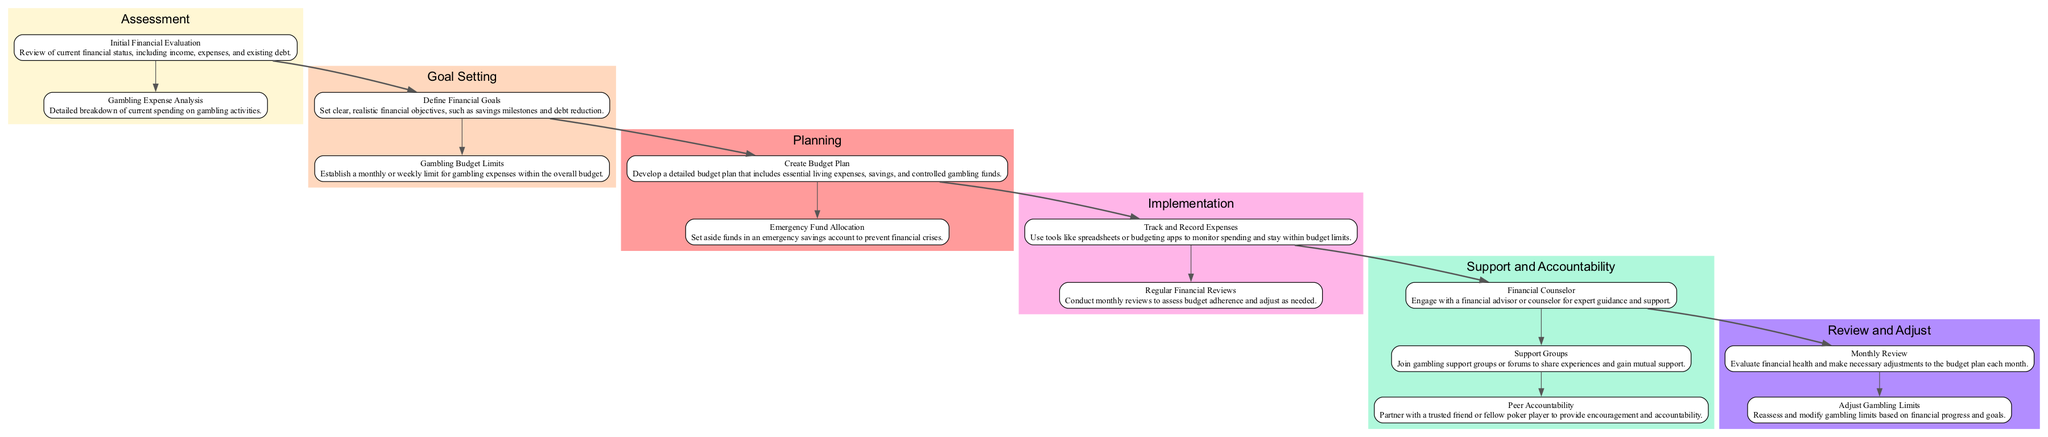What are the first two components in the Assessment stage? The first two components in the Assessment stage are "Initial Financial Evaluation" and "Gambling Expense Analysis." They both provide a foundation for understanding financial health and gambling habits.
Answer: Initial Financial Evaluation, Gambling Expense Analysis How many stages are there in the clinical pathway? The clinical pathway consists of six distinct stages, including Assessment, Goal Setting, Planning, Implementation, Support and Accountability, and Review and Adjust. This structure helps in managing gambling expenses effectively.
Answer: 6 What does the Planning stage focus on? The Planning stage focuses on creating a solid budget plan and allocating funds for emergencies. These components are essential for maintaining financial stability and managing gambling expenses.
Answer: Create Budget Plan, Emergency Fund Allocation Which stage includes "Track and Record Expenses"? "Track and Record Expenses" is included in the Implementation stage, where the focus is on actively managing and monitoring gambling expenditures to adhere to the established budget.
Answer: Implementation What are the last two components of the Support and Accountability stage? The last two components of the Support and Accountability stage are "Support Groups" and "Peer Accountability." These components emphasize the importance of community and partnerships in maintaining financial responsibility and reducing gambling habits.
Answer: Support Groups, Peer Accountability How does "Adjust Gambling Limits" relate to the Review and Adjust stage? "Adjust Gambling Limits" is one of the key components in the Review and Adjust stage. It emphasizes the ongoing need to evaluate gambling expenditures based on financial health and goals. This reflects the iterative nature of financial management in relation to gambling.
Answer: Ongoing evaluation and modification of limits What primary action is recommended in the Stage of Implementation? The primary action recommended in the Implementation stage is to "Track and Record Expenses," where individuals are encouraged to use tools to closely monitor their gambling spending relative to their budget limits. This facilitates accountability and control.
Answer: Track and Record Expenses Which component suggests seeking professional guidance? The component that suggests seeking professional guidance is "Financial Counselor," found in the Support and Accountability stage. Engaging with a financial advisor is crucial for expert advice and more effective money management strategies related to gambling.
Answer: Financial Counselor 